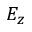Convert formula to latex. <formula><loc_0><loc_0><loc_500><loc_500>E _ { z }</formula> 